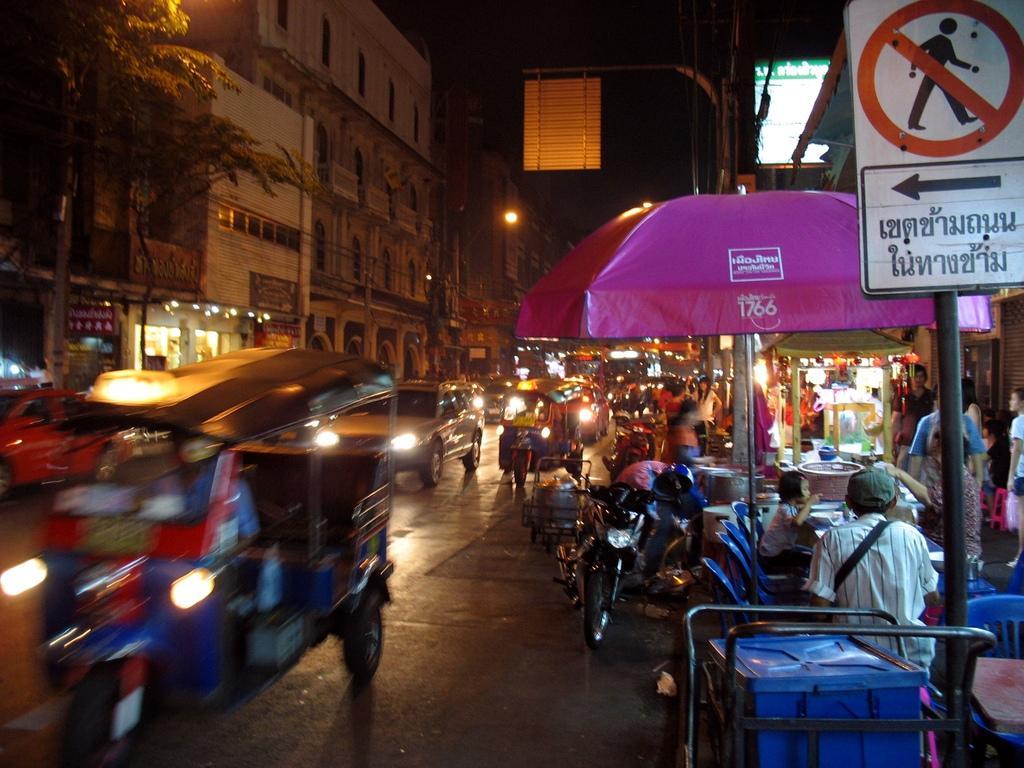How would you summarize this image in a sentence or two? This image is clicked on the road. In the front, we can see many vehicles on the road. On the right, there is an ice-cream box along with an umbrella. On the left, we can see buildings along with the trees. On the right, there are poles along with boards. At the top, there is sky. At the bottom, there is a road. 